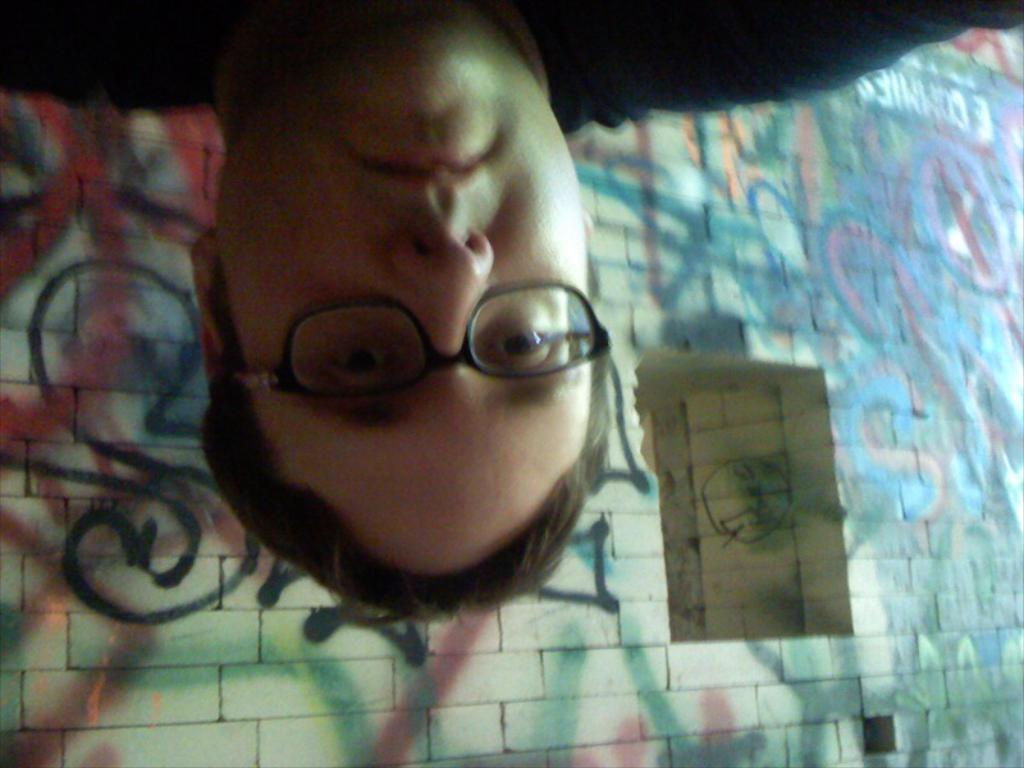Who or what is present in the image? There is a person in the image. What architectural feature can be seen in the image? There is a window in the image. What type of decoration is present on the walls in the image? There are wall paintings in the image. Can you determine the time of day based on the image? The image may have been taken during the night. How does the person in the image fold their arms in harmony with the wall paintings? There is no indication in the image that the person is folding their arms or that the wall paintings are related to harmony. 